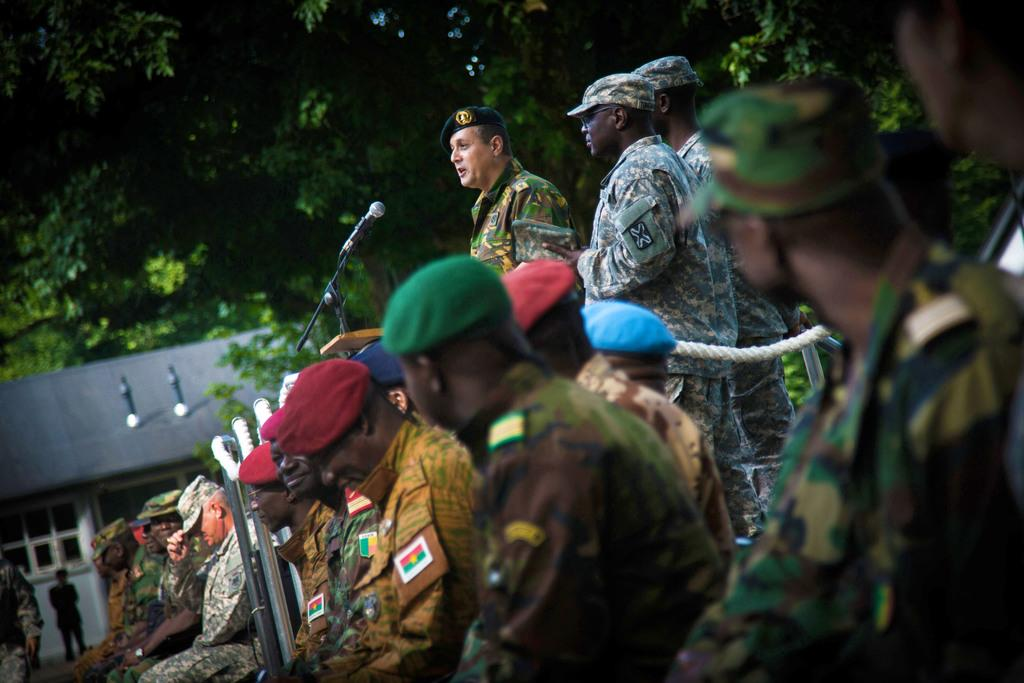How many people are in the image? There is a group of people in the image, but the exact number is not specified. What are some of the people wearing? Some of the people are wearing caps. What are the people in the image doing? Some people are sitting, while others are standing. What objects can be seen in the image related to ropes and poles? There are ropes and poles in the image. What device is present for amplifying sound? There is a microphone (mic) in the image. What type of structure is visible in the image? There is a house with a window in the image. What can be seen in the background of the image? Trees are visible in the background of the image. What type of yam is being used as a prop in the image? There is no yam present in the image. What type of footwear is visible on the people in the image? The provided facts do not mention any footwear, so we cannot determine the type of boots or shoes worn by the people in the image. 